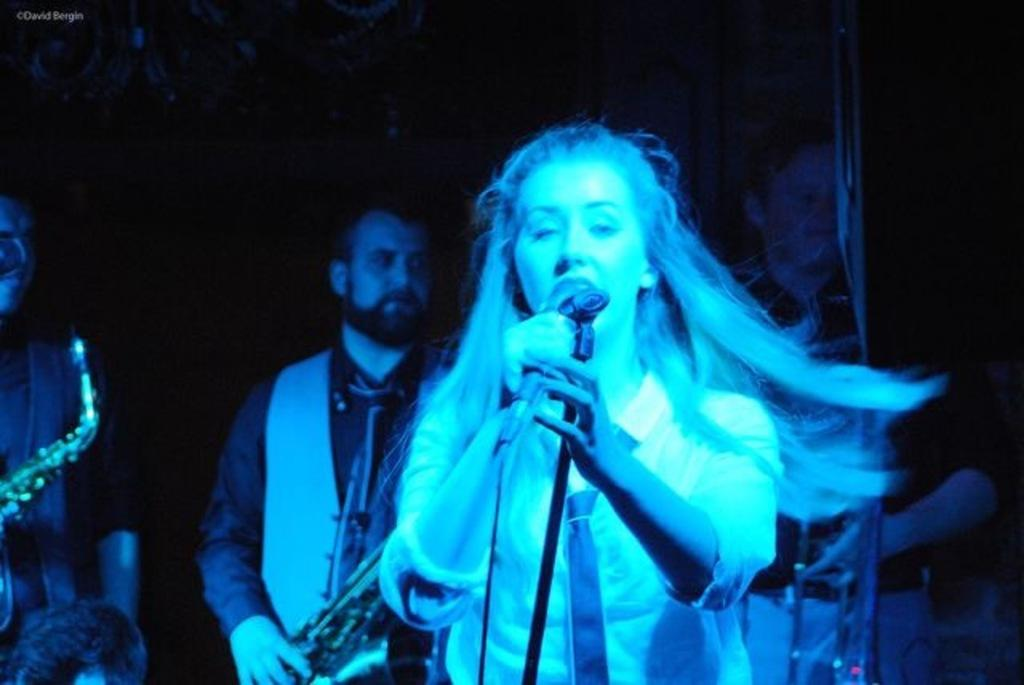What are the persons in the image doing? The persons in the image are playing musical instruments. Can you describe the woman in the image? The woman in the image is holding a mic and singing something. What is the woman's role in the image? The woman is likely the lead singer, as she is holding a mic and singing. What type of coal is being used to fuel the instruments in the image? There is no coal present in the image, and musical instruments do not require coal for fuel. 